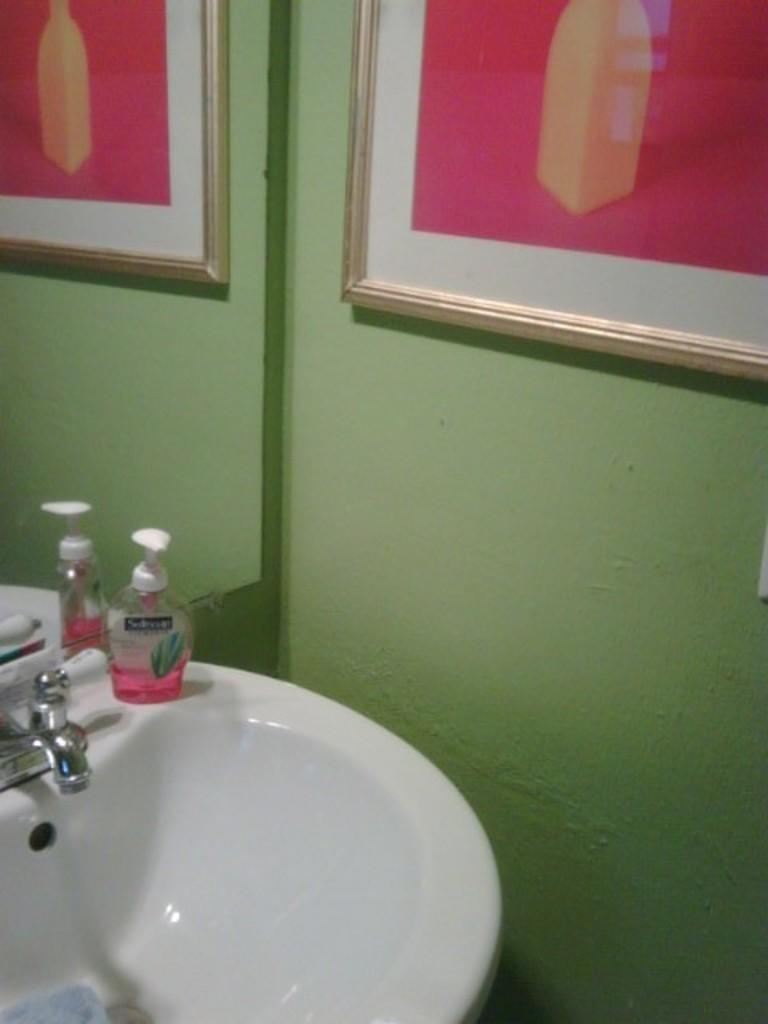What is the main fixture in the image? There is a sink in the image. What is attached to the sink? There is a tap in the image. What object is visible near the sink? There is a bottle in the image. What is hanging on the wall in the image? There is a photo frame on the wall in the image. What is used for self-reflection in the image? There is a mirror in the image. What is reflected in the mirror? The mirror reflects a photo frame. What type of lead can be seen in the image? There is no lead present in the image. What kind of meat is being prepared in the image? There is no meat or any indication of food preparation in the image. 